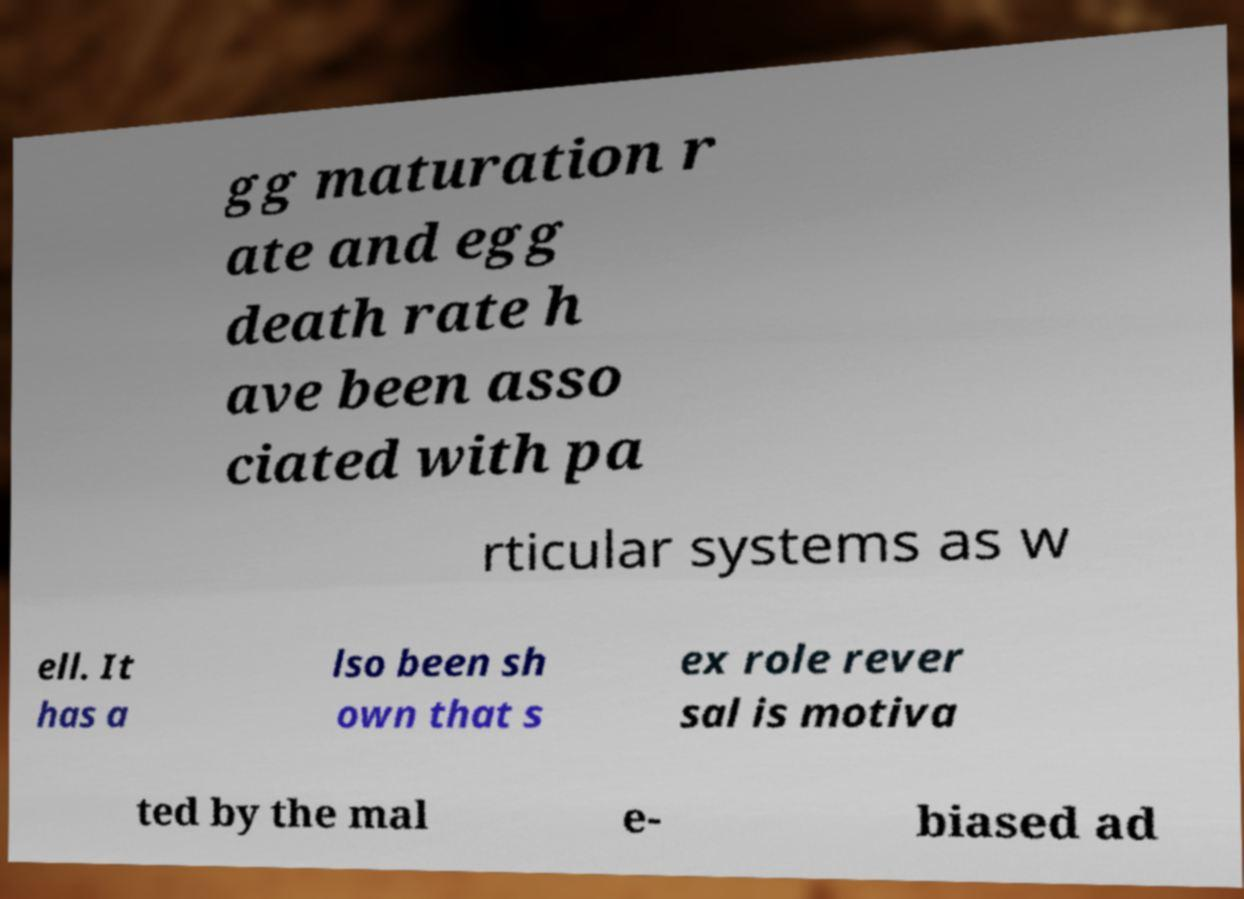Could you assist in decoding the text presented in this image and type it out clearly? gg maturation r ate and egg death rate h ave been asso ciated with pa rticular systems as w ell. It has a lso been sh own that s ex role rever sal is motiva ted by the mal e- biased ad 